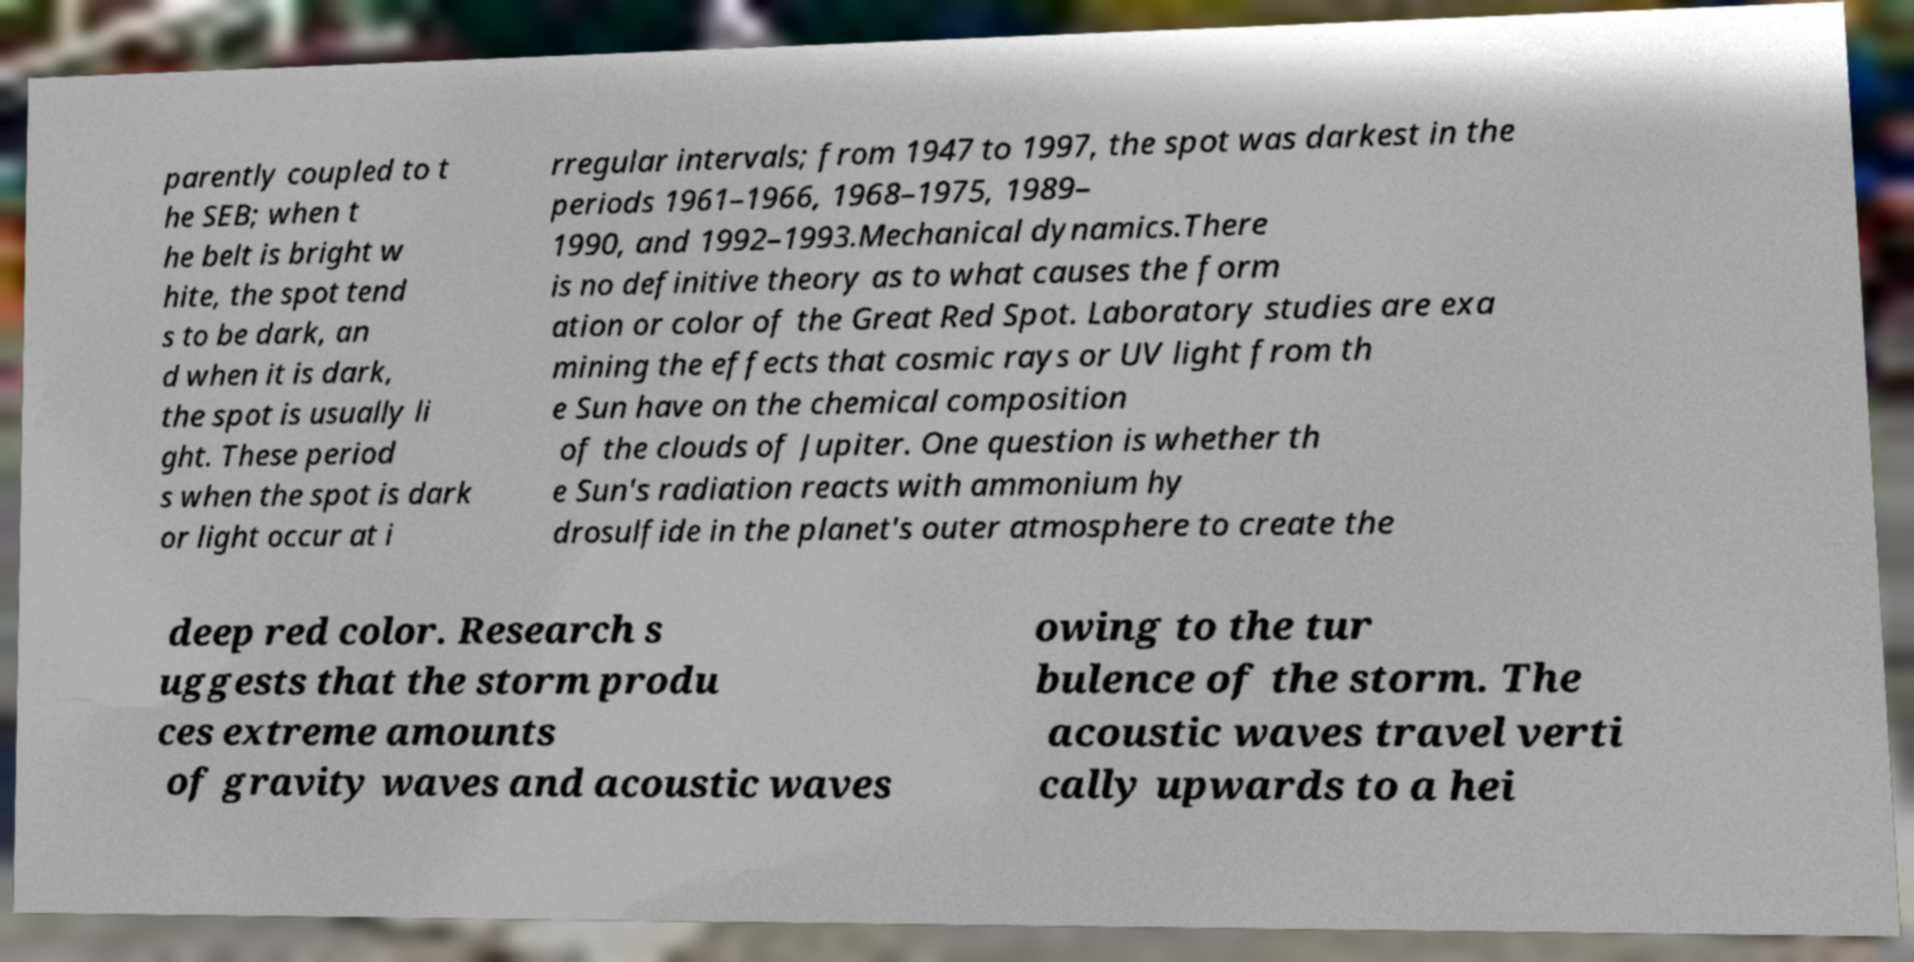Please identify and transcribe the text found in this image. parently coupled to t he SEB; when t he belt is bright w hite, the spot tend s to be dark, an d when it is dark, the spot is usually li ght. These period s when the spot is dark or light occur at i rregular intervals; from 1947 to 1997, the spot was darkest in the periods 1961–1966, 1968–1975, 1989– 1990, and 1992–1993.Mechanical dynamics.There is no definitive theory as to what causes the form ation or color of the Great Red Spot. Laboratory studies are exa mining the effects that cosmic rays or UV light from th e Sun have on the chemical composition of the clouds of Jupiter. One question is whether th e Sun's radiation reacts with ammonium hy drosulfide in the planet's outer atmosphere to create the deep red color. Research s uggests that the storm produ ces extreme amounts of gravity waves and acoustic waves owing to the tur bulence of the storm. The acoustic waves travel verti cally upwards to a hei 